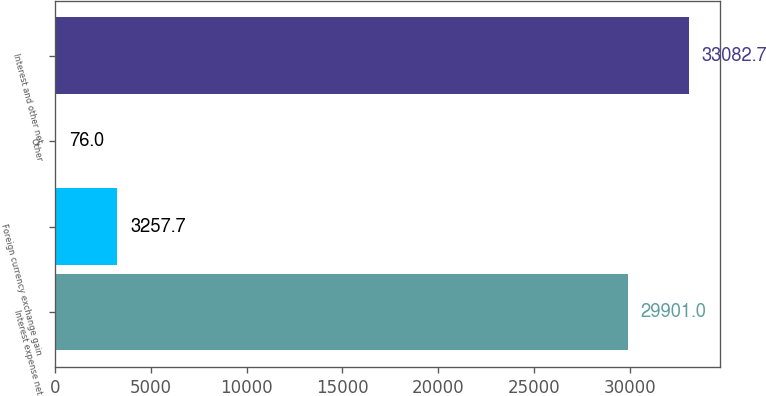Convert chart to OTSL. <chart><loc_0><loc_0><loc_500><loc_500><bar_chart><fcel>Interest expense net<fcel>Foreign currency exchange gain<fcel>Other<fcel>Interest and other net<nl><fcel>29901<fcel>3257.7<fcel>76<fcel>33082.7<nl></chart> 